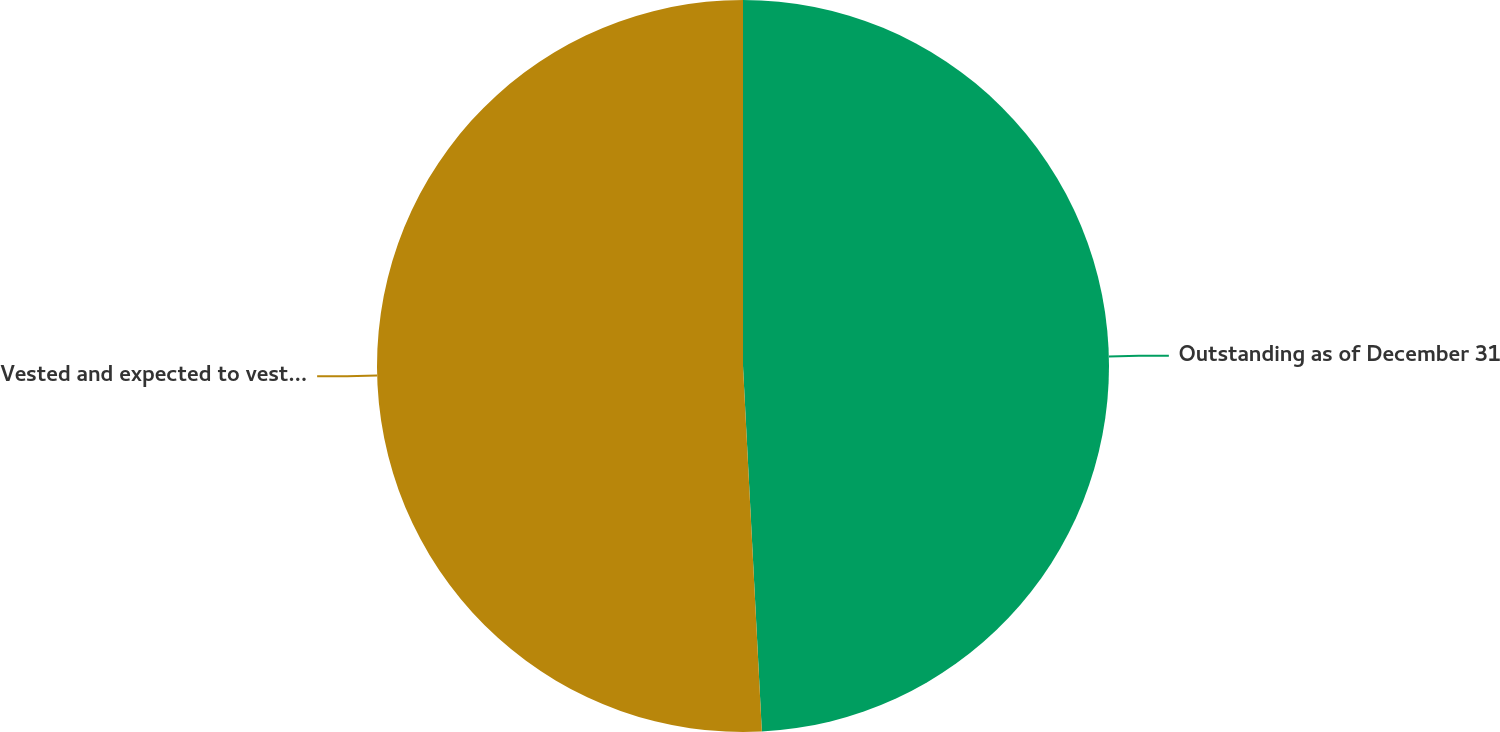<chart> <loc_0><loc_0><loc_500><loc_500><pie_chart><fcel>Outstanding as of December 31<fcel>Vested and expected to vest as<nl><fcel>49.18%<fcel>50.82%<nl></chart> 